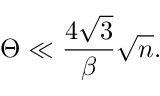Convert formula to latex. <formula><loc_0><loc_0><loc_500><loc_500>\Theta \ll \frac { 4 \sqrt { 3 } } { \beta } \sqrt { n } .</formula> 